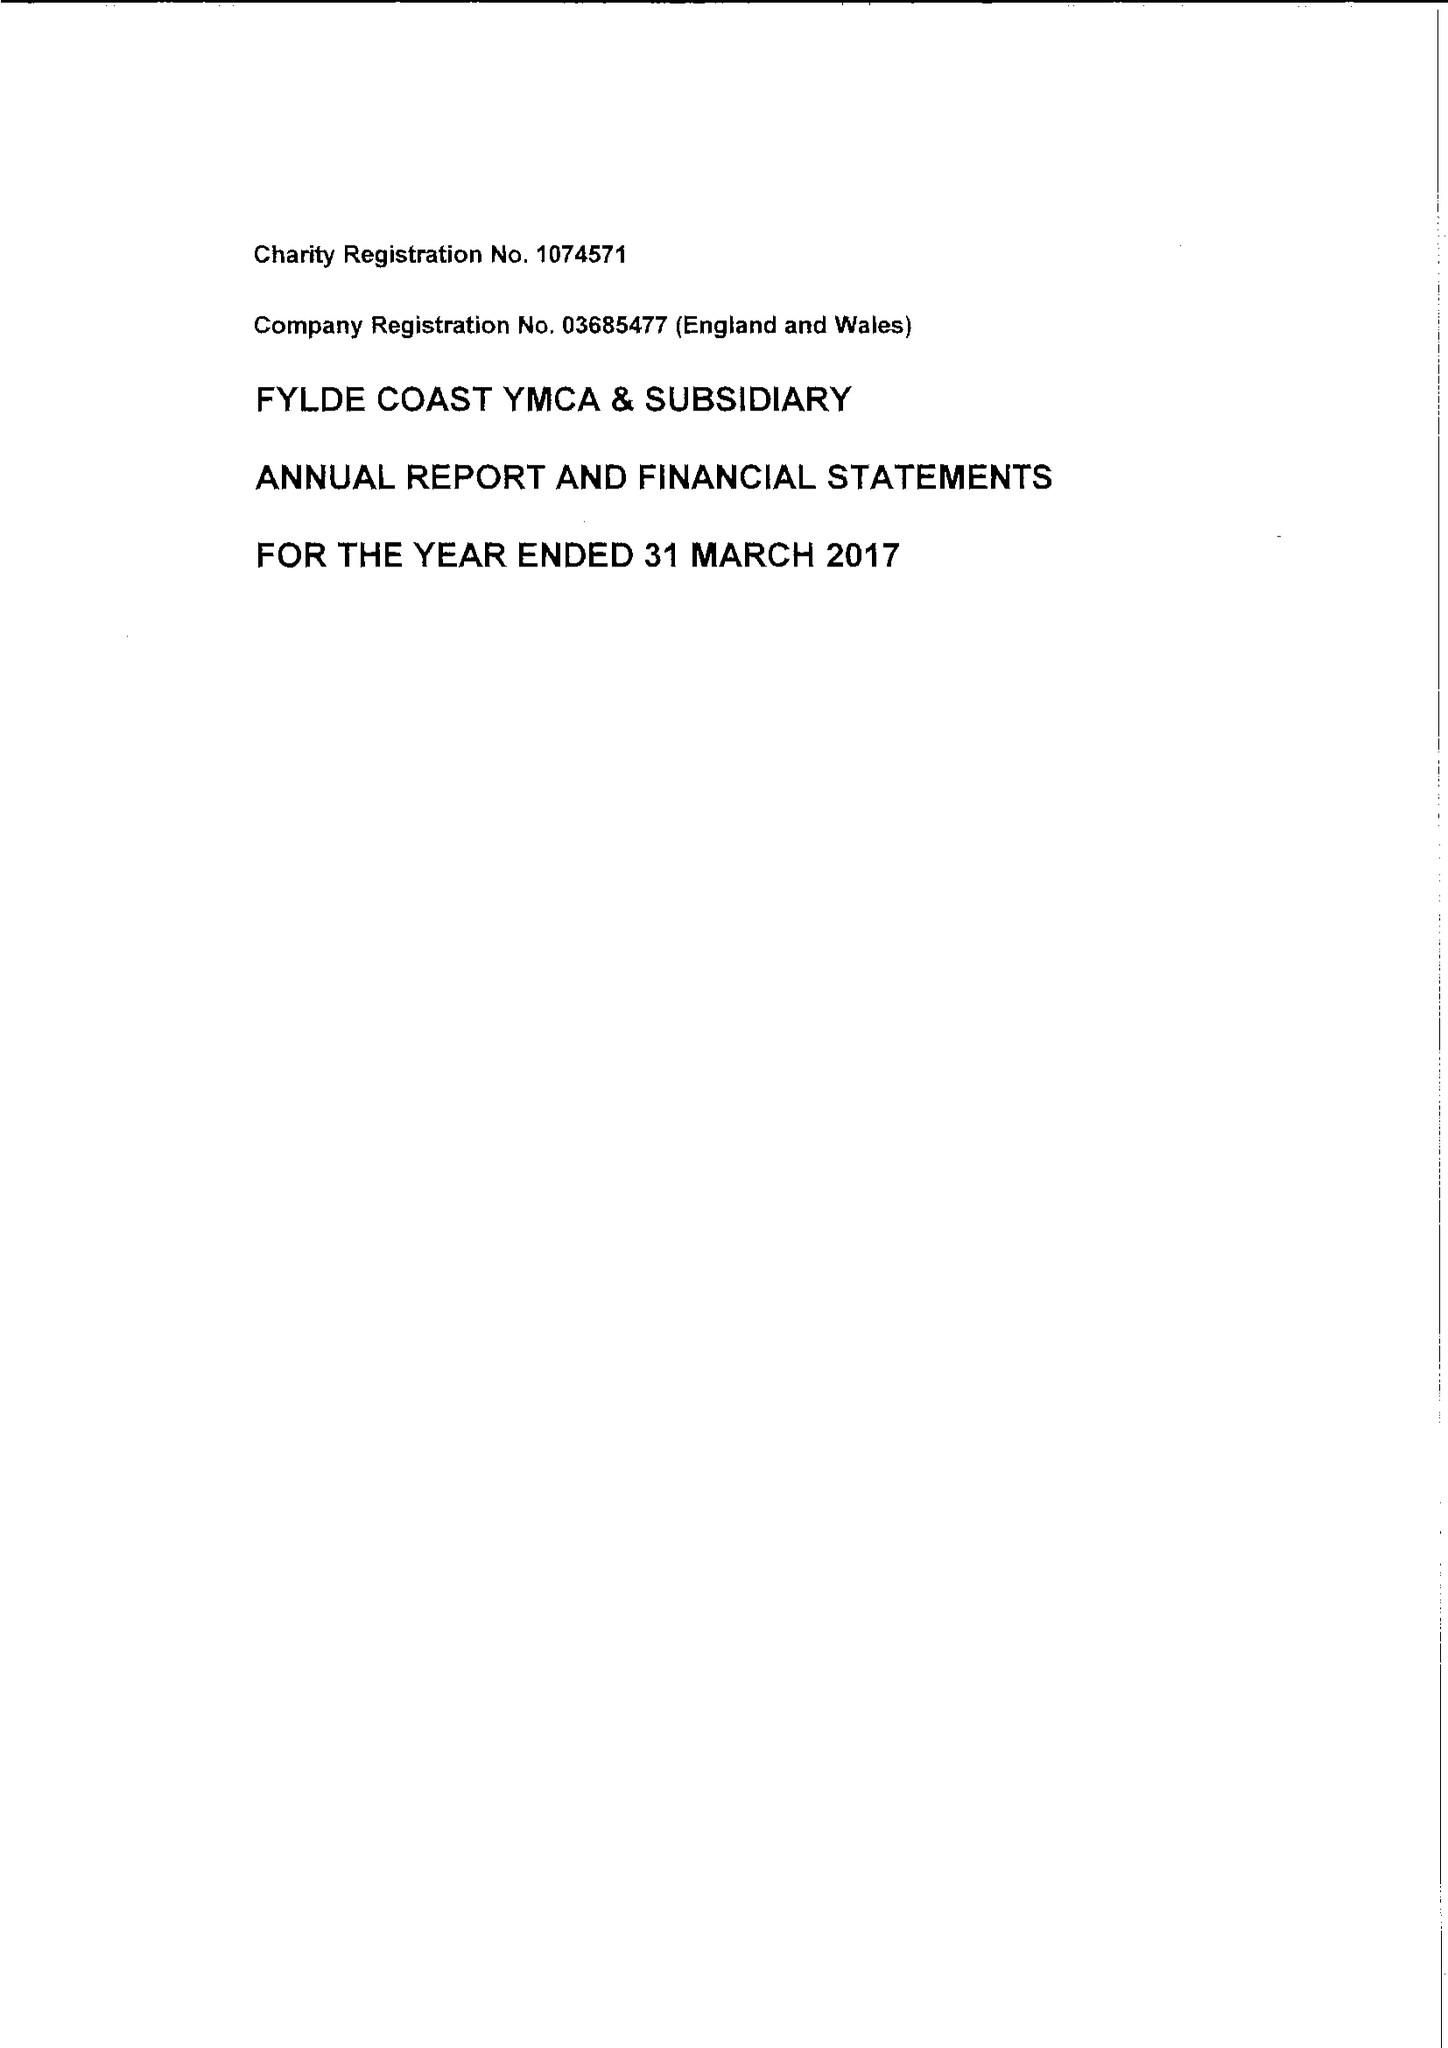What is the value for the charity_name?
Answer the question using a single word or phrase. Fylde Coast Ymca 